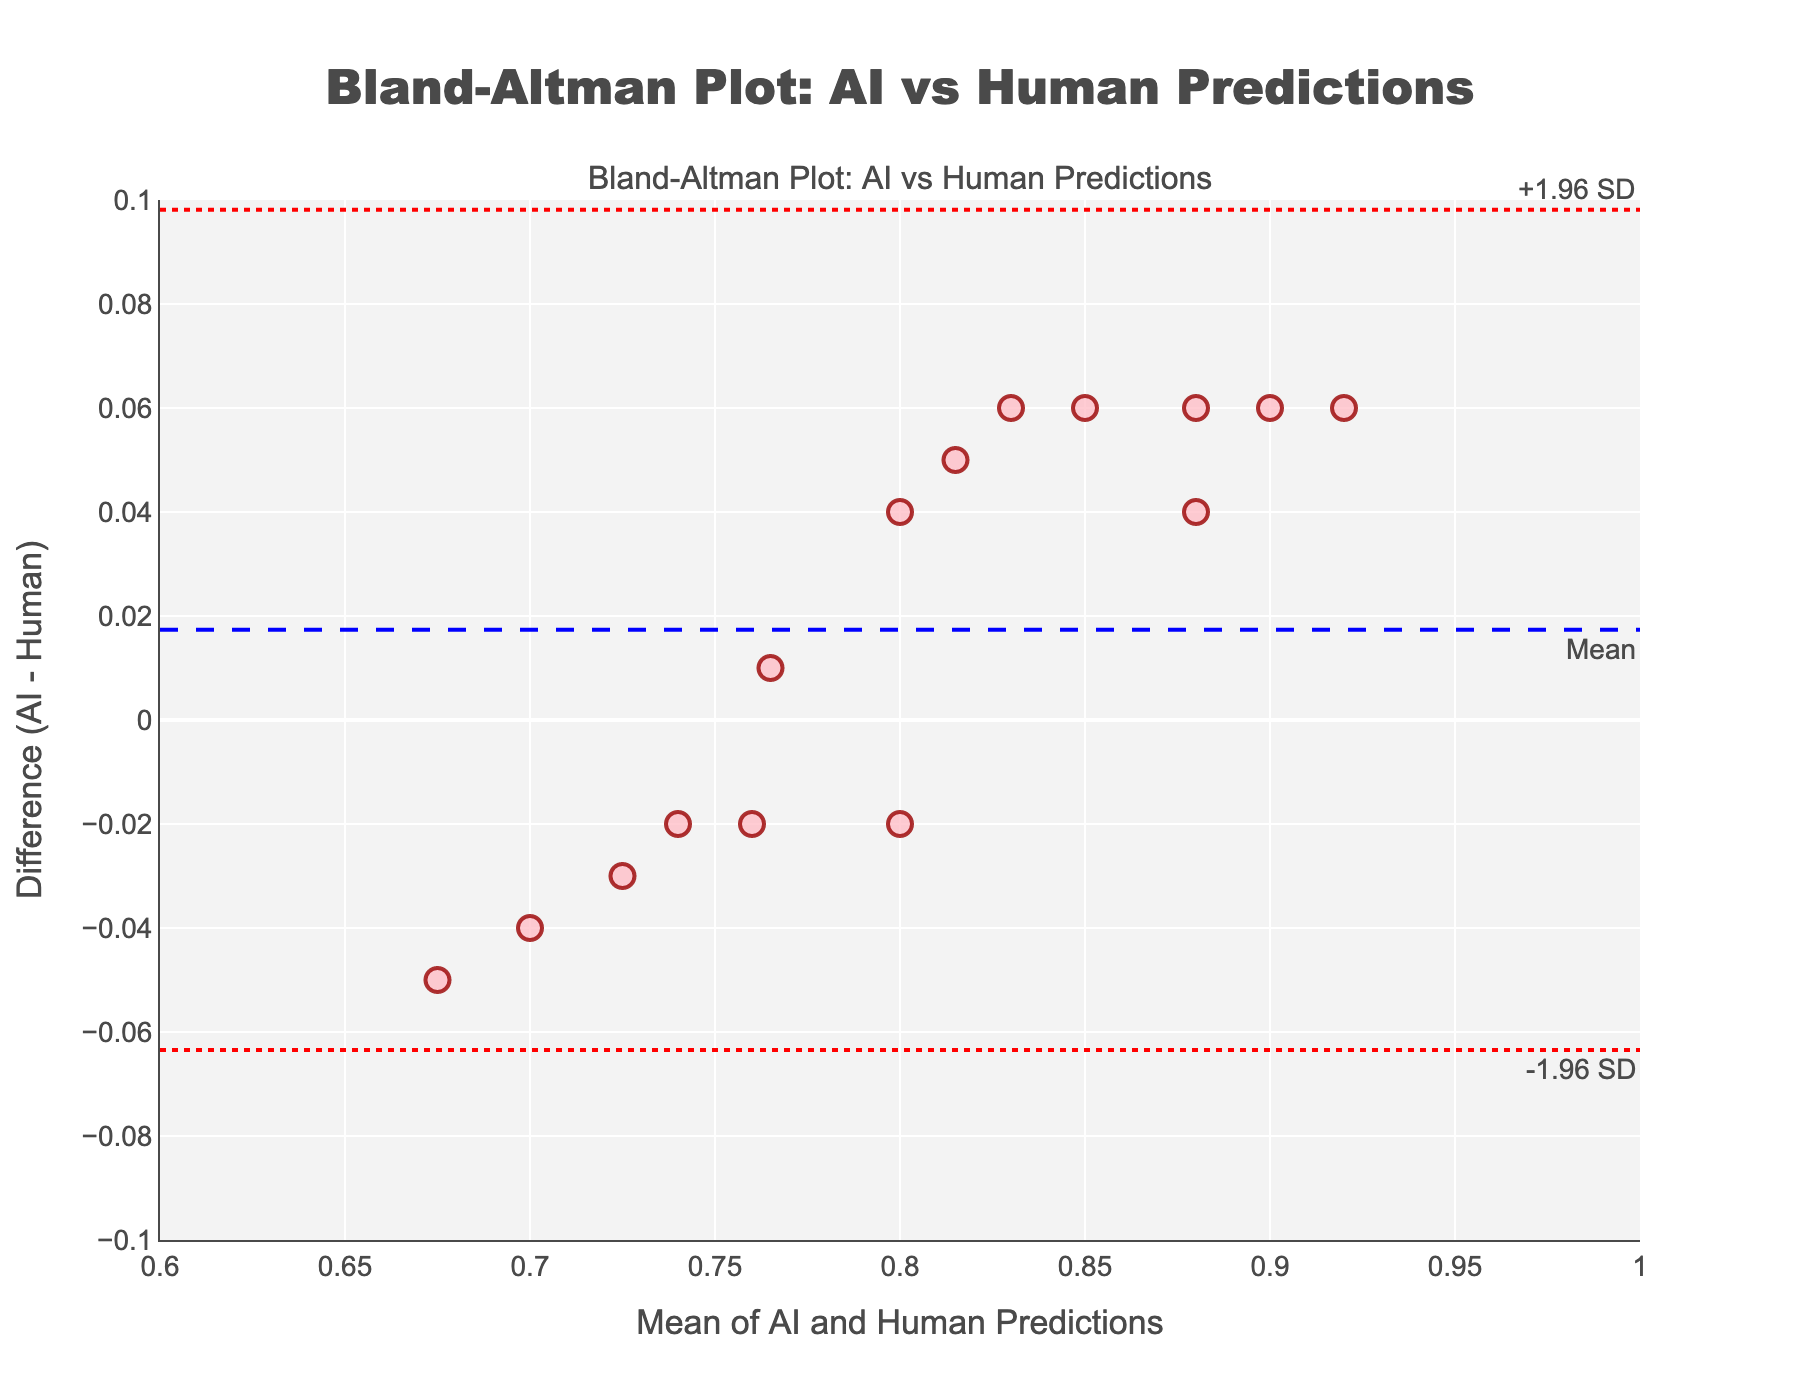What is the title of the figure? The title is placed at the top of the figure and provides a concise summary of what the plot is about, indicating its purpose.
Answer: Bland-Altman Plot: AI vs Human Predictions How many data points are displayed in the plot? Each marker or point on the plot represents one data point. Counting them will give the total number.
Answer: 15 What is represented by the x-axis and y-axis? The x-axis represents the mean of AI and Human predictions, while the y-axis represents the difference between AI and Human predictions. This can be gleaned from the axis titles provided.
Answer: The x-axis is the mean, and the y-axis is the difference What do the dashed and dotted lines represent in the plot? The plot contains a dashed line and two dotted lines. The blue dashed line represents the mean difference, while the red dotted lines represent ±1.96 SD (limits of agreement).
Answer: The mean difference and limits of agreement Is there any data point that lies outside the limits of agreement? To determine this, check if any point lies outside the red dotted lines (limits of agreement).
Answer: No What is the mean of the differences between the AI and Human predictions? The mean difference is represented by the dashed blue line. Its value is annotated next to the line.
Answer: Approximately 0.02 What are the upper and lower limits of agreement? The upper and lower limits are represented by the red dotted lines, with annotations indicating their values.
Answer: Approximately 0.068 and -0.028 Do the AI or Human predictions tend to be higher on average, based on the plot? Observing the y-axis, if most points have positive values, AI predictions are higher; if negative, Human predictions are higher. The mean difference (blue dashed line) also provides this information.
Answer: AI predictions are slightly higher What can be inferred if most data points are clustered around the zero line on the y-axis? If most data points are clustered around the zero line, it indicates that AI and Human predictions are very close to each other, suggesting good agreement.
Answer: AI and Human predictions are generally in good agreement Which patient IDs are most likely aligned closely in predictions between AI and Humans? Closely aligned predictions will have data points near the zero line on the y-axis. Identify the points closest to zero and use their x-axis positions to trace back to the Patient ID from the data.
Answer: Patients with IDs P004, P006, and P010 